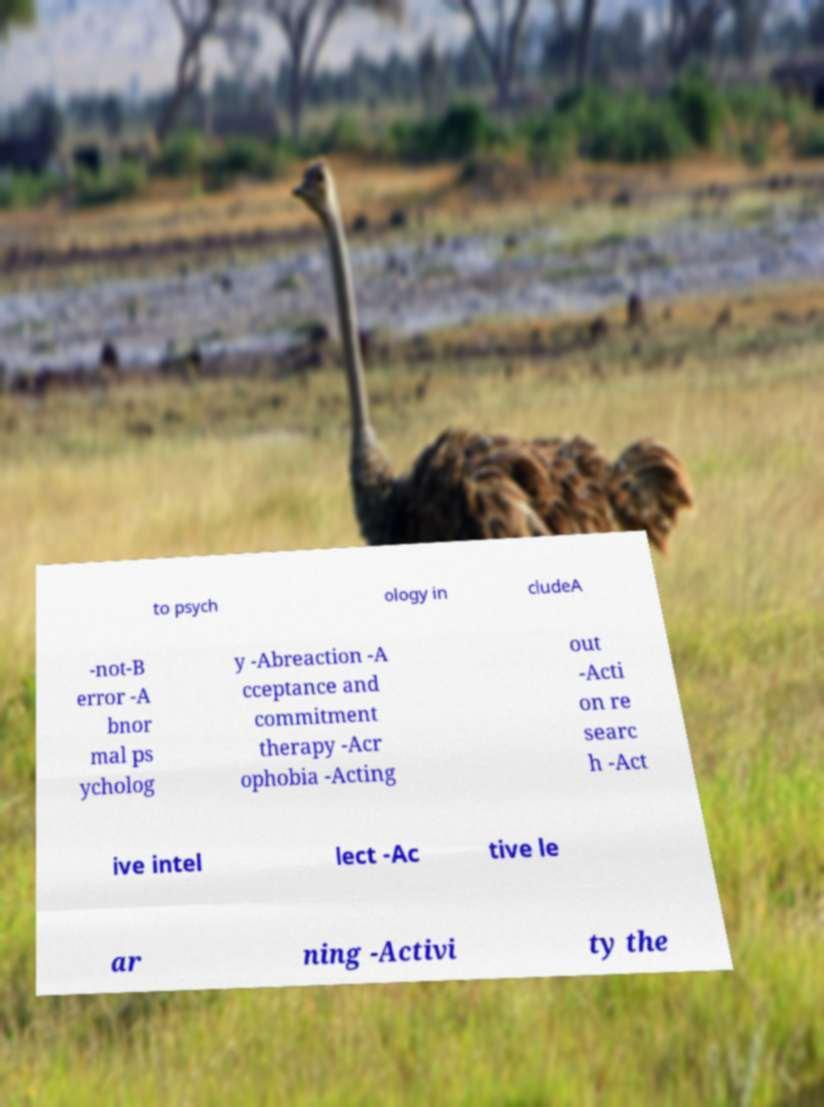I need the written content from this picture converted into text. Can you do that? to psych ology in cludeA -not-B error -A bnor mal ps ycholog y -Abreaction -A cceptance and commitment therapy -Acr ophobia -Acting out -Acti on re searc h -Act ive intel lect -Ac tive le ar ning -Activi ty the 